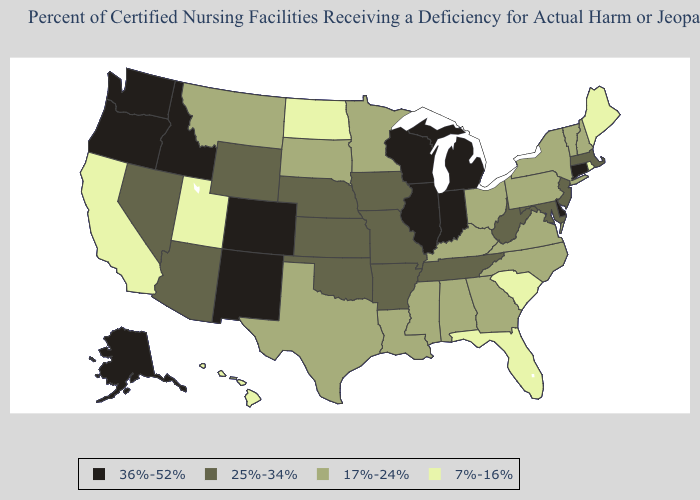Does Maryland have a lower value than North Carolina?
Be succinct. No. Does Arkansas have the highest value in the USA?
Answer briefly. No. What is the highest value in the USA?
Be succinct. 36%-52%. Name the states that have a value in the range 36%-52%?
Quick response, please. Alaska, Colorado, Connecticut, Delaware, Idaho, Illinois, Indiana, Michigan, New Mexico, Oregon, Washington, Wisconsin. What is the highest value in the South ?
Short answer required. 36%-52%. What is the lowest value in states that border Wisconsin?
Answer briefly. 17%-24%. Does Maryland have the highest value in the USA?
Answer briefly. No. What is the value of Kansas?
Give a very brief answer. 25%-34%. Name the states that have a value in the range 36%-52%?
Write a very short answer. Alaska, Colorado, Connecticut, Delaware, Idaho, Illinois, Indiana, Michigan, New Mexico, Oregon, Washington, Wisconsin. How many symbols are there in the legend?
Be succinct. 4. Name the states that have a value in the range 7%-16%?
Short answer required. California, Florida, Hawaii, Maine, North Dakota, Rhode Island, South Carolina, Utah. Name the states that have a value in the range 36%-52%?
Concise answer only. Alaska, Colorado, Connecticut, Delaware, Idaho, Illinois, Indiana, Michigan, New Mexico, Oregon, Washington, Wisconsin. How many symbols are there in the legend?
Quick response, please. 4. Which states have the lowest value in the USA?
Be succinct. California, Florida, Hawaii, Maine, North Dakota, Rhode Island, South Carolina, Utah. What is the value of Tennessee?
Concise answer only. 25%-34%. 